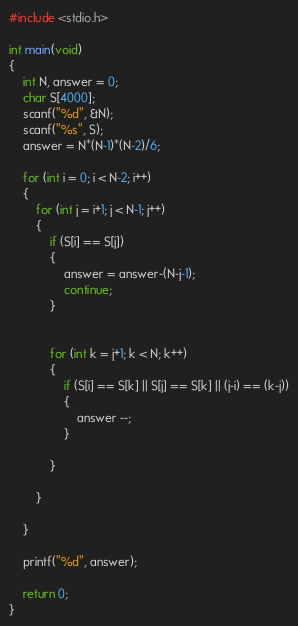<code> <loc_0><loc_0><loc_500><loc_500><_C_>#include <stdio.h>

int main(void)
{
    int N, answer = 0;
    char S[4000];
    scanf("%d", &N);
    scanf("%s", S);
    answer = N*(N-1)*(N-2)/6;

    for (int i = 0; i < N-2; i++)
    {
        for (int j = i+1; j < N-1; j++)
        {
            if (S[i] == S[j])
            {
                answer = answer-(N-j-1);
                continue;
            }
            

            for (int k = j+1; k < N; k++)
            {
                if (S[i] == S[k] || S[j] == S[k] || (j-i) == (k-j))
                {
                    answer --;
                }
                
            }
            
        }
        
    }

    printf("%d", answer);
    
    return 0;
}</code> 